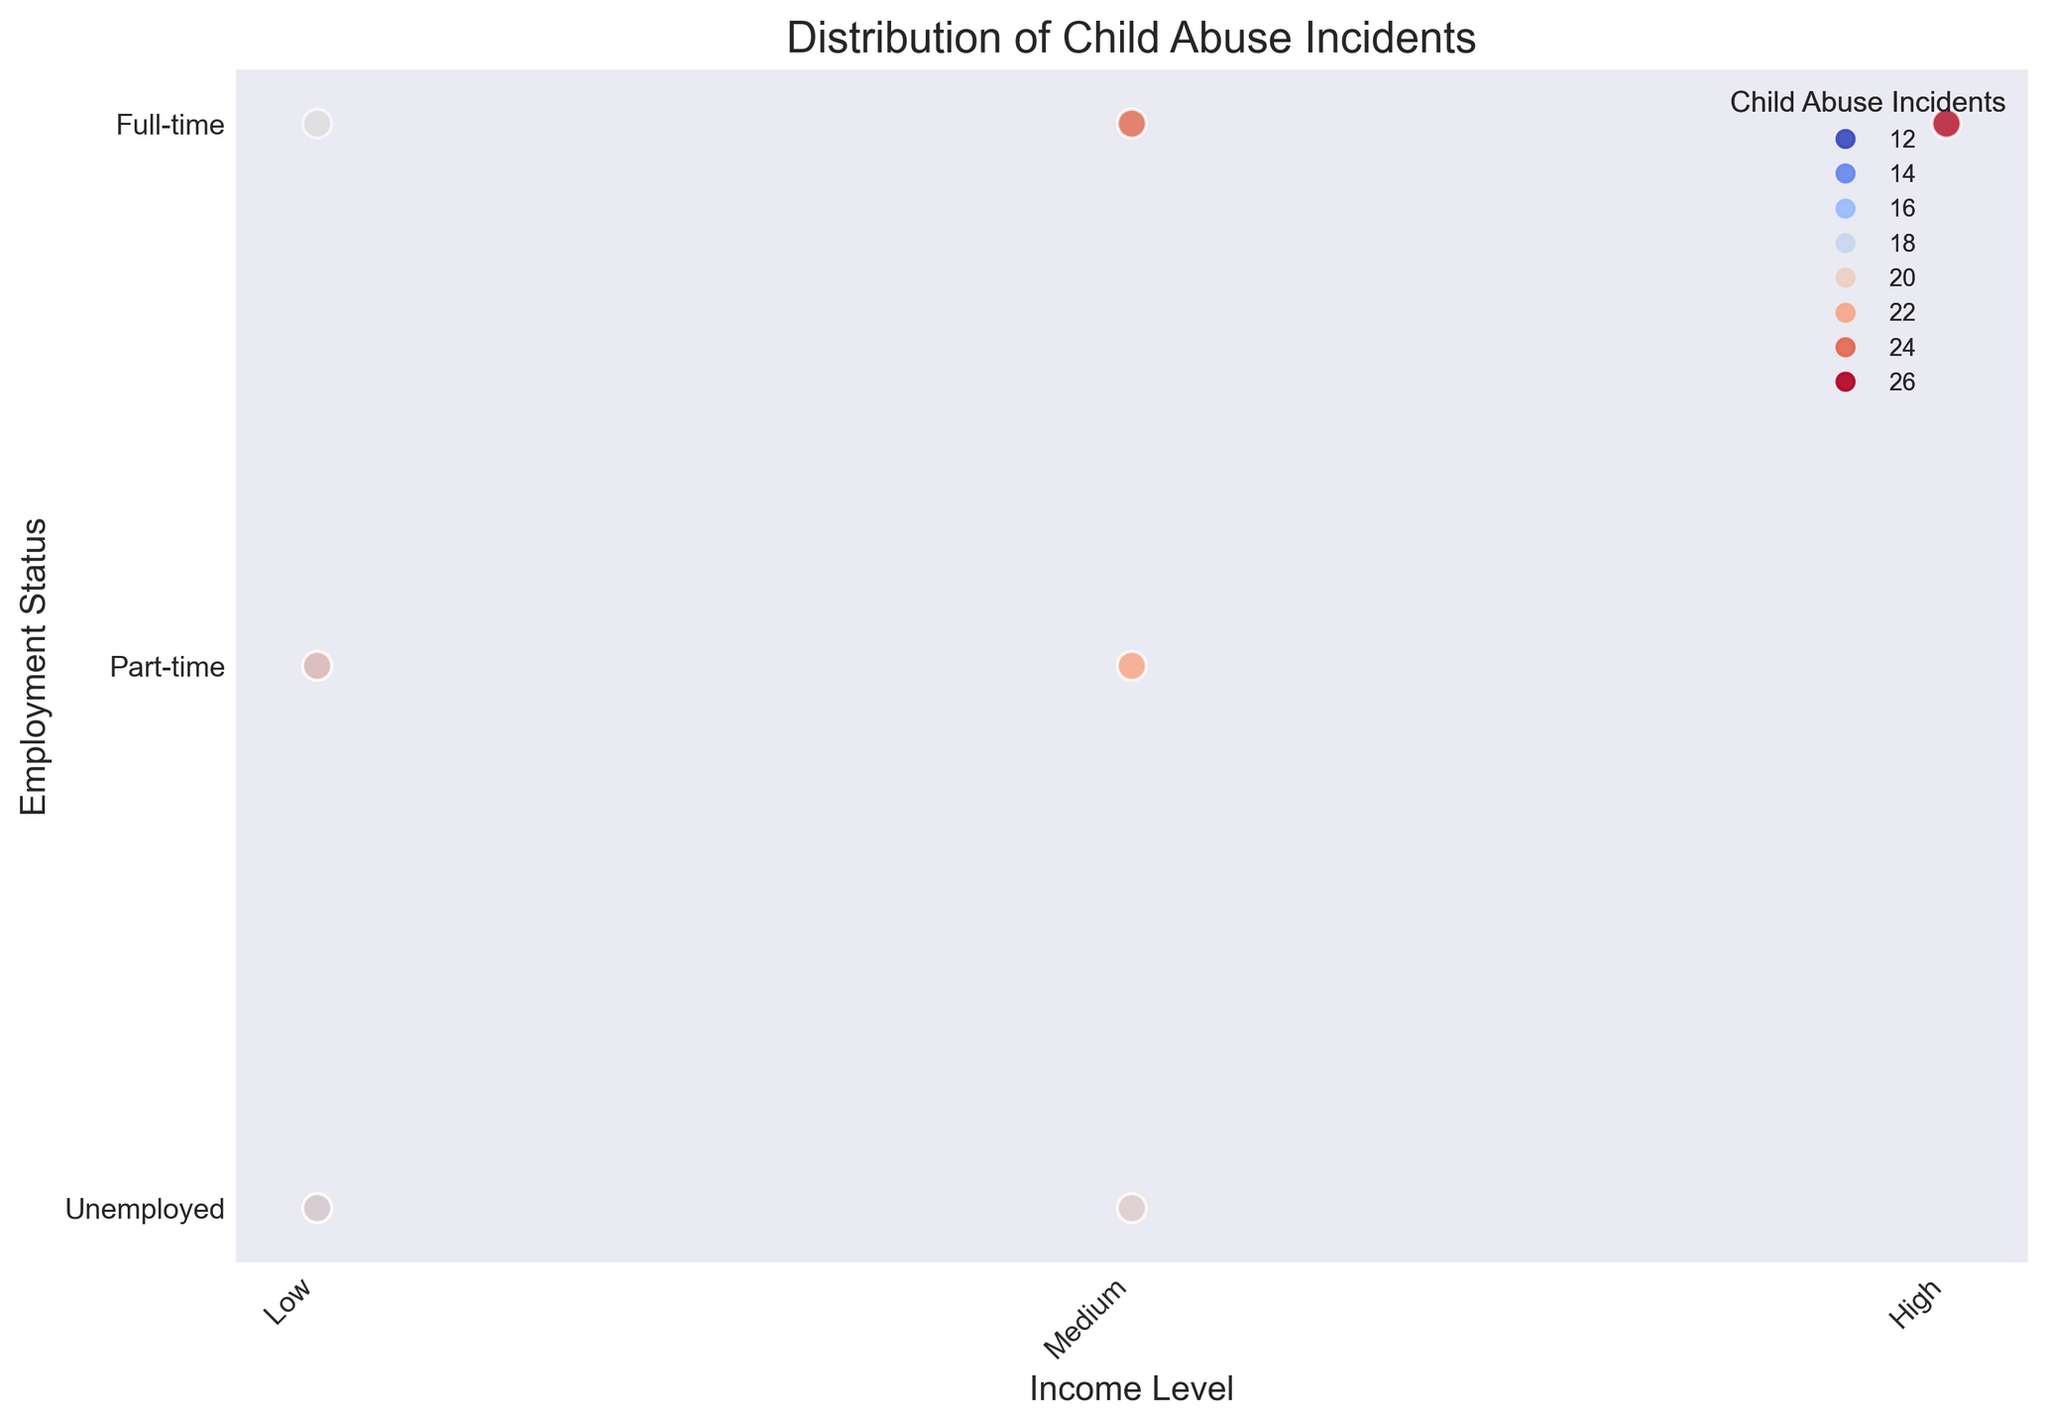Which income level and employment status combination has the highest number of child abuse incidents reported? Look for the combination of income level and employment status with the darkest color, indicating the highest number of child abuse incidents. The darkest color appears at the point corresponding to Low income level and Unemployed status.
Answer: Low income level and Unemployed status Which income level shows the least variation in child abuse incidents across different employment statuses? Compare the range of colors within each income level category across different employment statuses. The High-income level shows the least color variation, indicating a more consistent number of child abuse incidents.
Answer: High income level How does the number of child abuse incidents change with employment status in the Low-income group? Observe the color gradient for Low-income markers along different employment statuses. The number of incidents decreases from Unemployed (dark color) to Part-time and further to Full-time (lighter colors).
Answer: Decreases with more stable employment Which employment status category has the highest average number of child abuse incidents reported across all income levels? Calculate the average color (incident number) for each employment status level, considering all income levels. The darkest colors indicating higher incidents are most common in the Unemployed category.
Answer: Unemployed Is there any employment status where the Medium-income level report significantly fewer child abuse incidents compared to the Low-income level? Compare the colors between Low and Medium-income levels within each employment status category. In the "Part-time" employment status, the incidents are significantly lower in Medium-income (lighter color) compared to Low-income.
Answer: Part-time Does a higher income level correlate with fewer child abuse incidents? Observe the color gradient from Low to High-income levels across employment statuses. Generally, the colors indicating incidents become lighter from Low to High-income levels, suggesting a negative correlation.
Answer: Yes What is the relationship between education level and the number of child abuse incidents in different income levels? The plot does not display education level explicitly, but indirect observation might show trends based on the employment status and income levels. Higher education levels correlate with higher income levels, which are generally lighter in color, indicating fewer incidents.
Answer: Higher education correlates with fewer incidents Which combination of income level and employment status reports the lowest number of child abuse incidents? Look for the combination with the lightest color. The combination of High income level and Full-time employment status has the lightest color on the plot.
Answer: High income and Full-time 